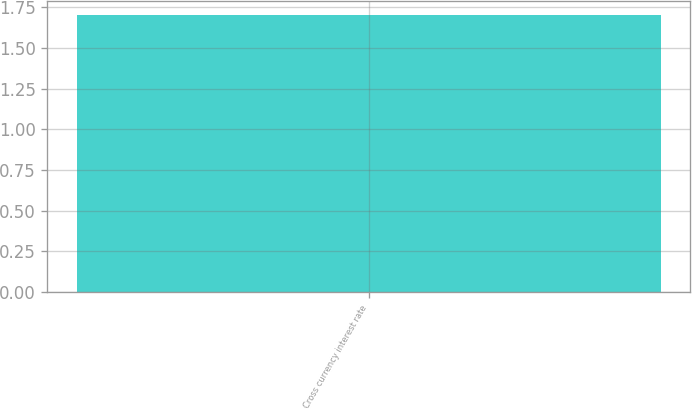Convert chart to OTSL. <chart><loc_0><loc_0><loc_500><loc_500><bar_chart><fcel>Cross currency interest rate<nl><fcel>1.7<nl></chart> 